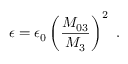<formula> <loc_0><loc_0><loc_500><loc_500>\epsilon = \epsilon _ { 0 } \left ( \frac { M _ { 0 3 } } { M _ { 3 } } \right ) ^ { 2 } .</formula> 